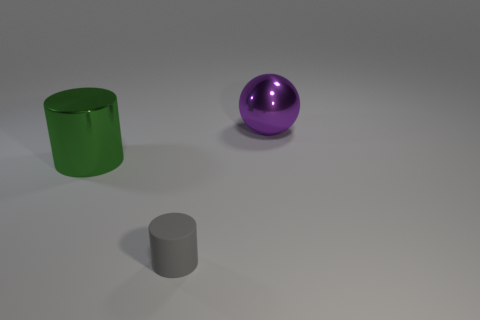What number of objects are metal cylinders or small gray cylinders?
Your answer should be very brief. 2. There is a big object that is to the left of the shiny thing behind the big green shiny object; what is it made of?
Your response must be concise. Metal. What is the color of the ball that is the same size as the green shiny object?
Make the answer very short. Purple. What is the material of the object that is right of the cylinder in front of the shiny object that is in front of the metallic sphere?
Provide a succinct answer. Metal. What number of things are either big shiny things in front of the large purple metallic sphere or large things that are to the right of the big green object?
Offer a terse response. 2. What is the shape of the thing right of the thing in front of the green object?
Your answer should be compact. Sphere. Is there a yellow cube made of the same material as the gray cylinder?
Provide a short and direct response. No. What is the color of the small matte thing that is the same shape as the big green shiny thing?
Keep it short and to the point. Gray. Is the number of tiny gray matte objects in front of the metallic cylinder less than the number of gray cylinders behind the rubber thing?
Offer a very short reply. No. How many other objects are there of the same shape as the small gray rubber object?
Your answer should be compact. 1. 